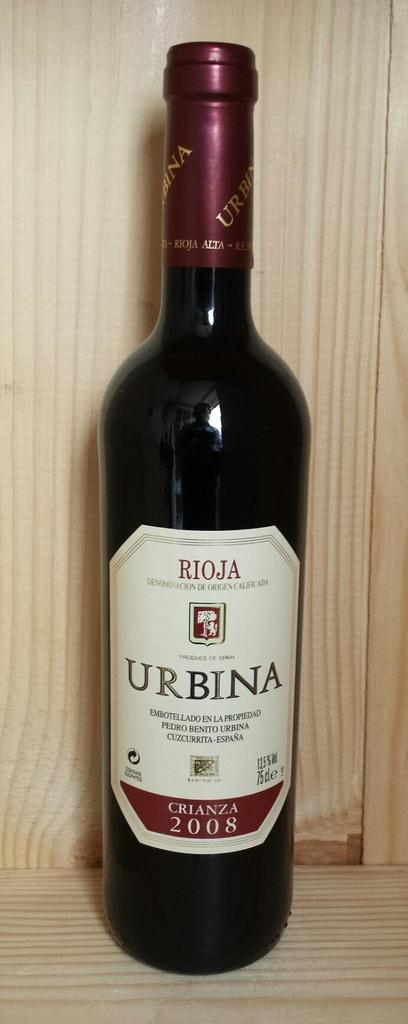<image>
Share a concise interpretation of the image provided. An unopened bottle of Urbina Rioja win from 2008. 